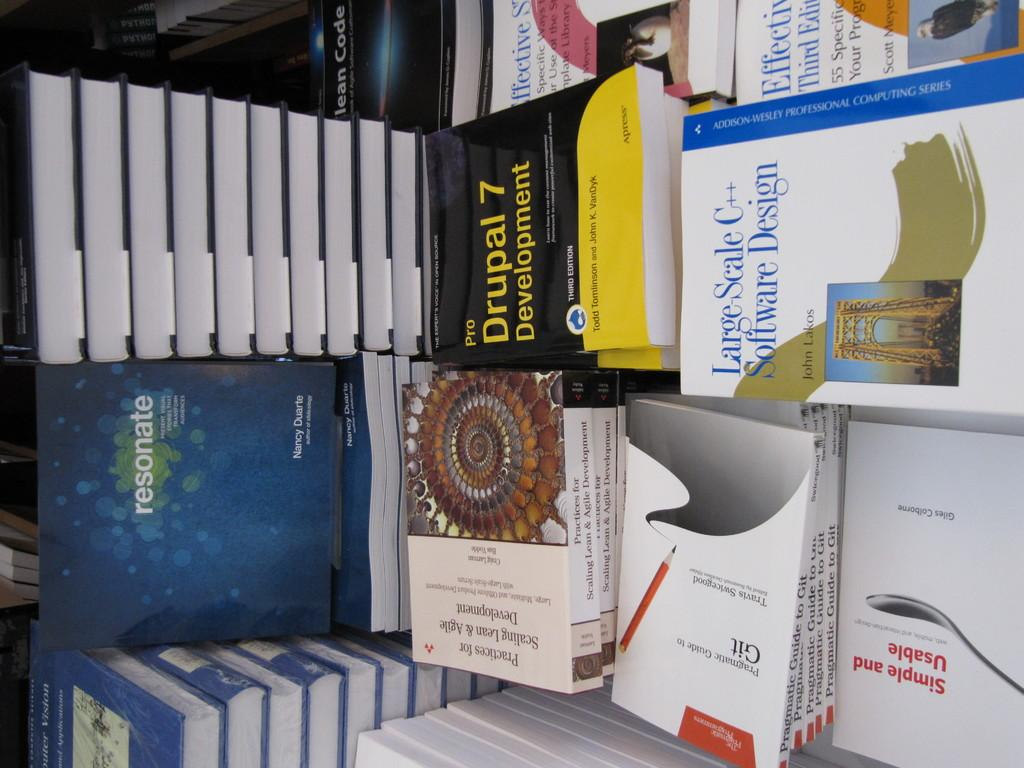<image>
Describe the image concisely. A table with a variety of book including Large Scale C++. 